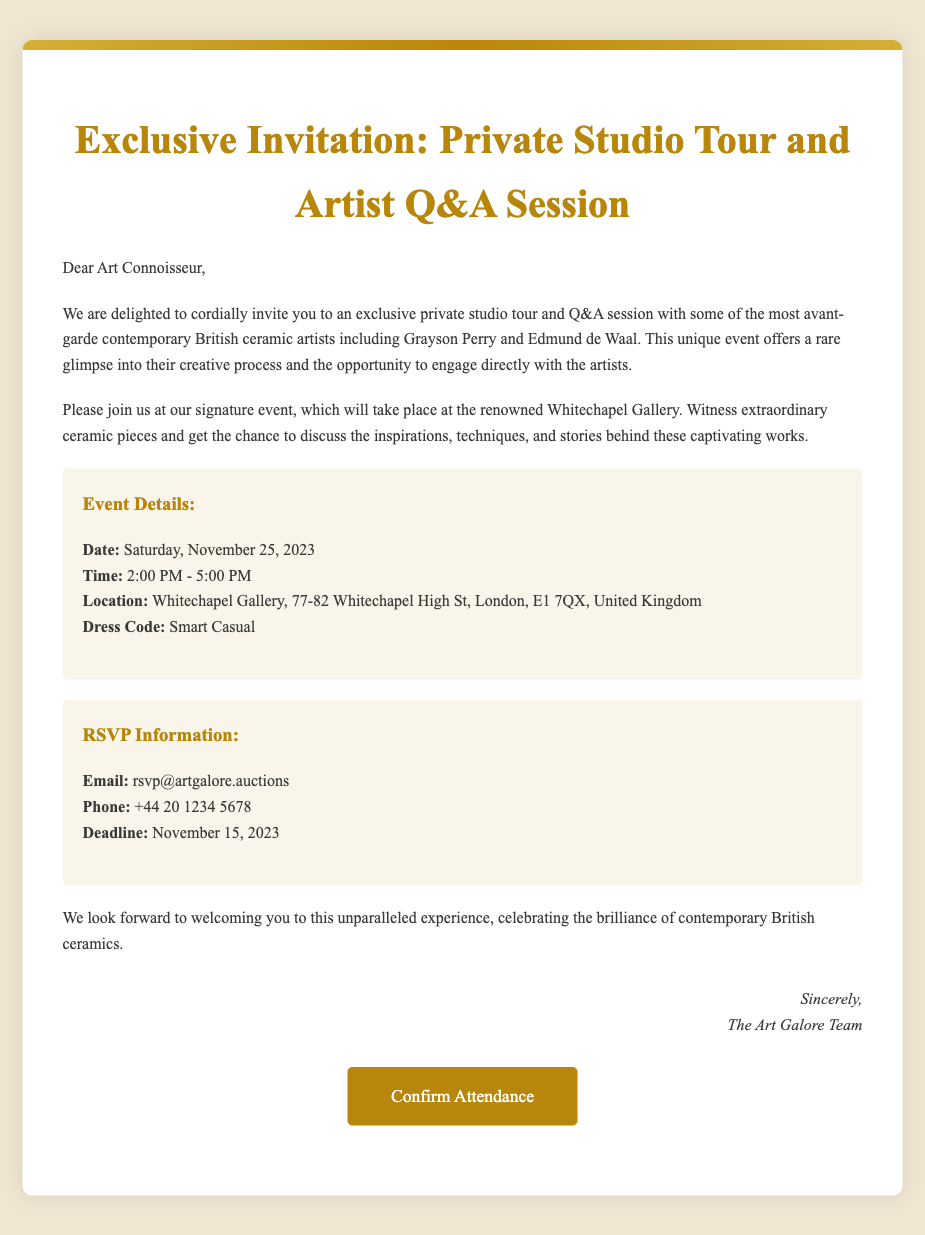what is the date of the event? The date of the event is explicitly mentioned in the event details section as Saturday, November 25, 2023.
Answer: Saturday, November 25, 2023 what time does the event start? The starting time of the event is specified in the event details section as 2:00 PM.
Answer: 2:00 PM where is the event taking place? The location of the event is clearly stated in the event details section as Whitechapel Gallery, 77-82 Whitechapel High St, London, E1 7QX, United Kingdom.
Answer: Whitechapel Gallery what is the dress code for the event? The dress code is specified in the event details section as smart casual.
Answer: Smart Casual what is the RSVP deadline? The RSVP deadline is provided in the RSVP information section as November 15, 2023.
Answer: November 15, 2023 how can attendees confirm their attendance? Attendees are instructed in the RSVP information section to email rsvp@artgalore.auctions to confirm their attendance.
Answer: rsvp@artgalore.auctions who are some of the featured artists at the event? The featured artists are mentioned in the invitation text as Grayson Perry and Edmund de Waal.
Answer: Grayson Perry and Edmund de Waal what is the phone number for RSVP inquiries? The phone number for RSVP inquiries is listed in the RSVP information section as +44 20 1234 5678.
Answer: +44 20 1234 5678 is there an opportunity to engage with the artists? The document invites attendees to engage directly with the artists during the Q&A session, indicating an opportunity for engagement.
Answer: Yes 